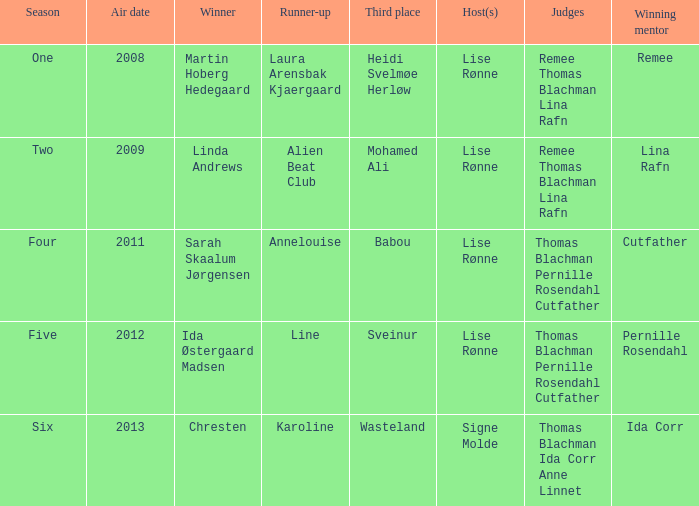Who came in third during the fourth season? Babou. 